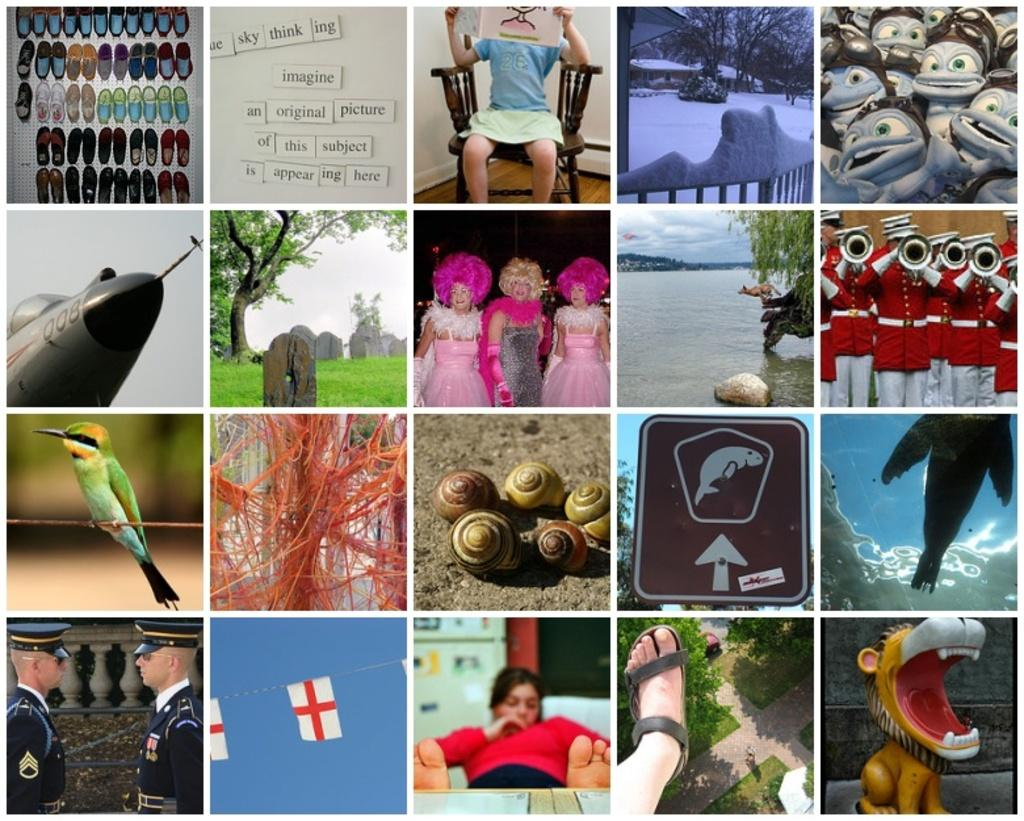What type of image is being described? The image is a collage of multiple images. How are the images arranged or combined in the collage? The provided facts do not specify the arrangement or combination of the images in the collage. What type of ground is visible in the image? There is no ground visible in the image, as it is a collage of multiple images. Who created the collage in the image? The provided facts do not mention the creator of the collage, so we cannot determine who made it. 